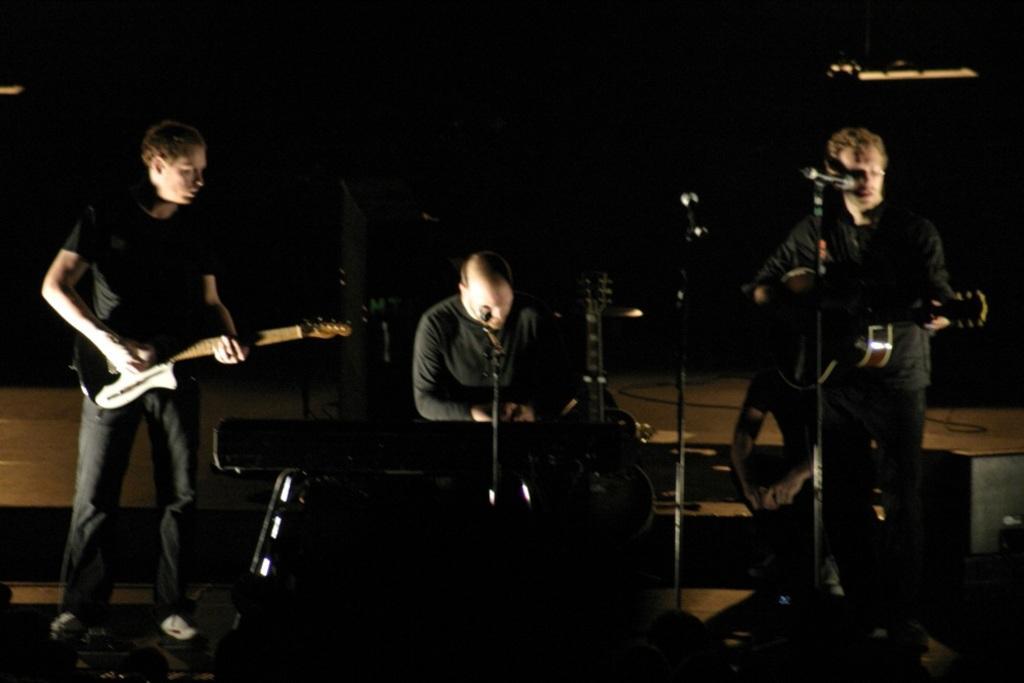Can you describe this image briefly? In this image there are three persons playing musical instruments. To the left the person is holding a guitar and he is wearing a black t shirt and black jeans. In the middle he is sitting and playing a piano and he is wearing black t shirt. To the right he is wearing black t shirt and he is holding a guitar and he is singing. There is a person behind him and the background is dark. 